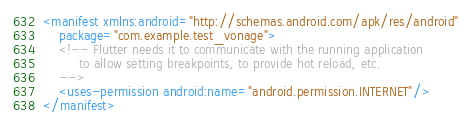<code> <loc_0><loc_0><loc_500><loc_500><_XML_><manifest xmlns:android="http://schemas.android.com/apk/res/android"
    package="com.example.test_vonage">
    <!-- Flutter needs it to communicate with the running application
         to allow setting breakpoints, to provide hot reload, etc.
    -->
    <uses-permission android:name="android.permission.INTERNET"/>
</manifest>
</code> 